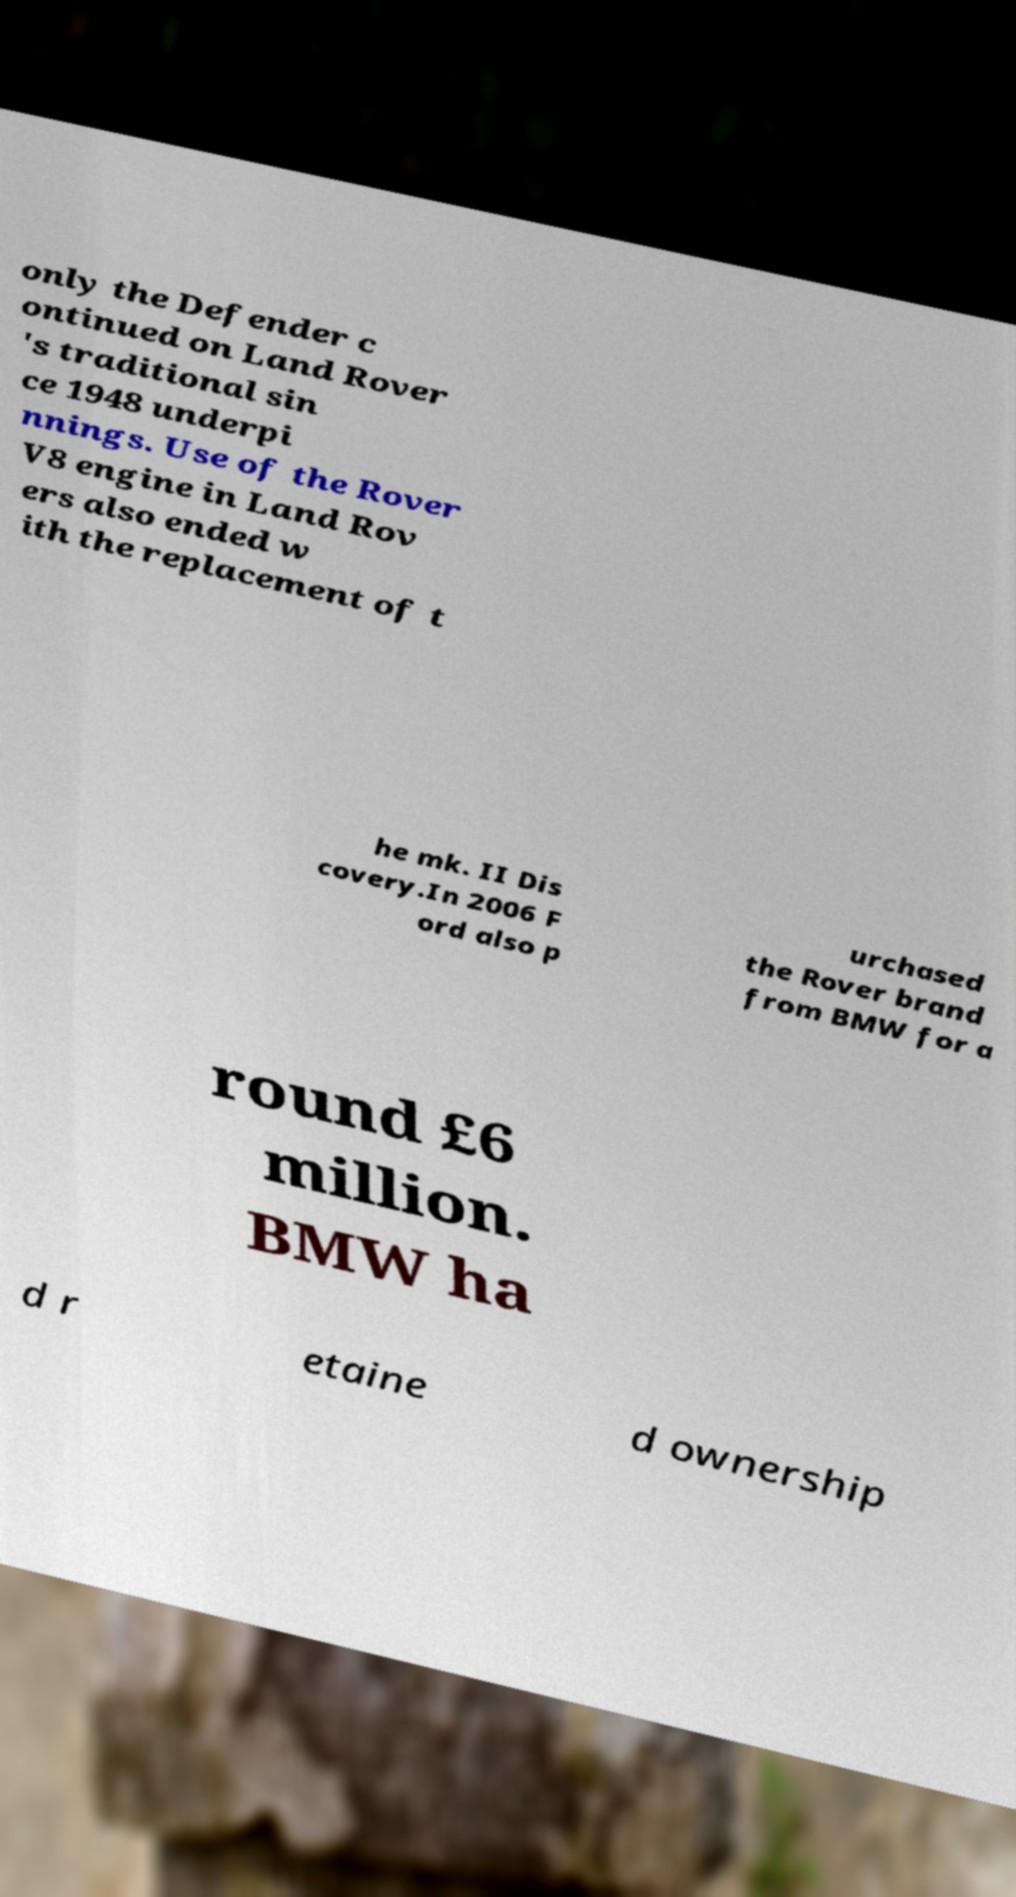Could you extract and type out the text from this image? only the Defender c ontinued on Land Rover 's traditional sin ce 1948 underpi nnings. Use of the Rover V8 engine in Land Rov ers also ended w ith the replacement of t he mk. II Dis covery.In 2006 F ord also p urchased the Rover brand from BMW for a round £6 million. BMW ha d r etaine d ownership 